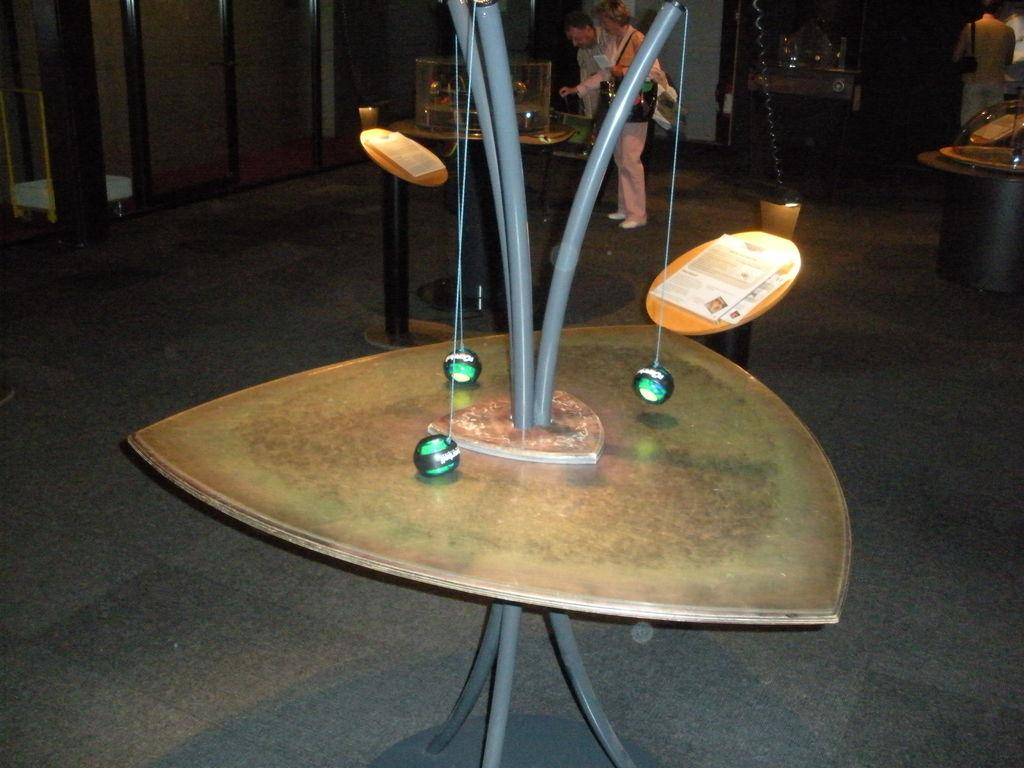What is the position of the table in the image? A table is inverted on another table in the image. Are there any objects attached to the table? Yes, there are three balls hanged to the legs of the table. Can you describe the background of the image? There are people in the background of the image. What is the name of the geese in the image? There are no geese present in the image. What type of appliance is being used by the people in the background? The provided facts do not mention any appliances being used by the people in the background. 